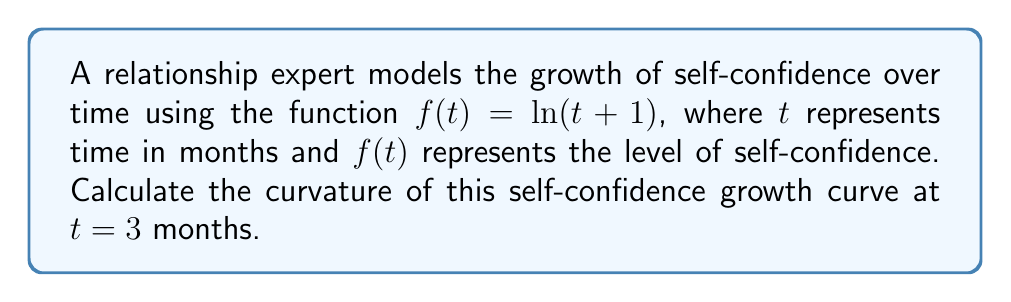Could you help me with this problem? To calculate the curvature of the self-confidence growth curve, we'll use the formula for the curvature of a planar curve:

$$\kappa = \frac{|f''(t)|}{(1 + [f'(t)]^2)^{3/2}}$$

Step 1: Calculate $f'(t)$
$$f'(t) = \frac{1}{t+1}$$

Step 2: Calculate $f''(t)$
$$f''(t) = -\frac{1}{(t+1)^2}$$

Step 3: Evaluate $f'(t)$ at $t = 3$
$$f'(3) = \frac{1}{3+1} = \frac{1}{4}$$

Step 4: Evaluate $f''(t)$ at $t = 3$
$$f''(3) = -\frac{1}{(3+1)^2} = -\frac{1}{16}$$

Step 5: Substitute values into the curvature formula
$$\kappa = \frac{|-\frac{1}{16}|}{(1 + [\frac{1}{4}]^2)^{3/2}}$$

Step 6: Simplify
$$\kappa = \frac{\frac{1}{16}}{(1 + \frac{1}{16})^{3/2}} = \frac{\frac{1}{16}}{(\frac{17}{16})^{3/2}} = \frac{16}{17^{3/2}}$$
Answer: $\frac{16}{17^{3/2}}$ 